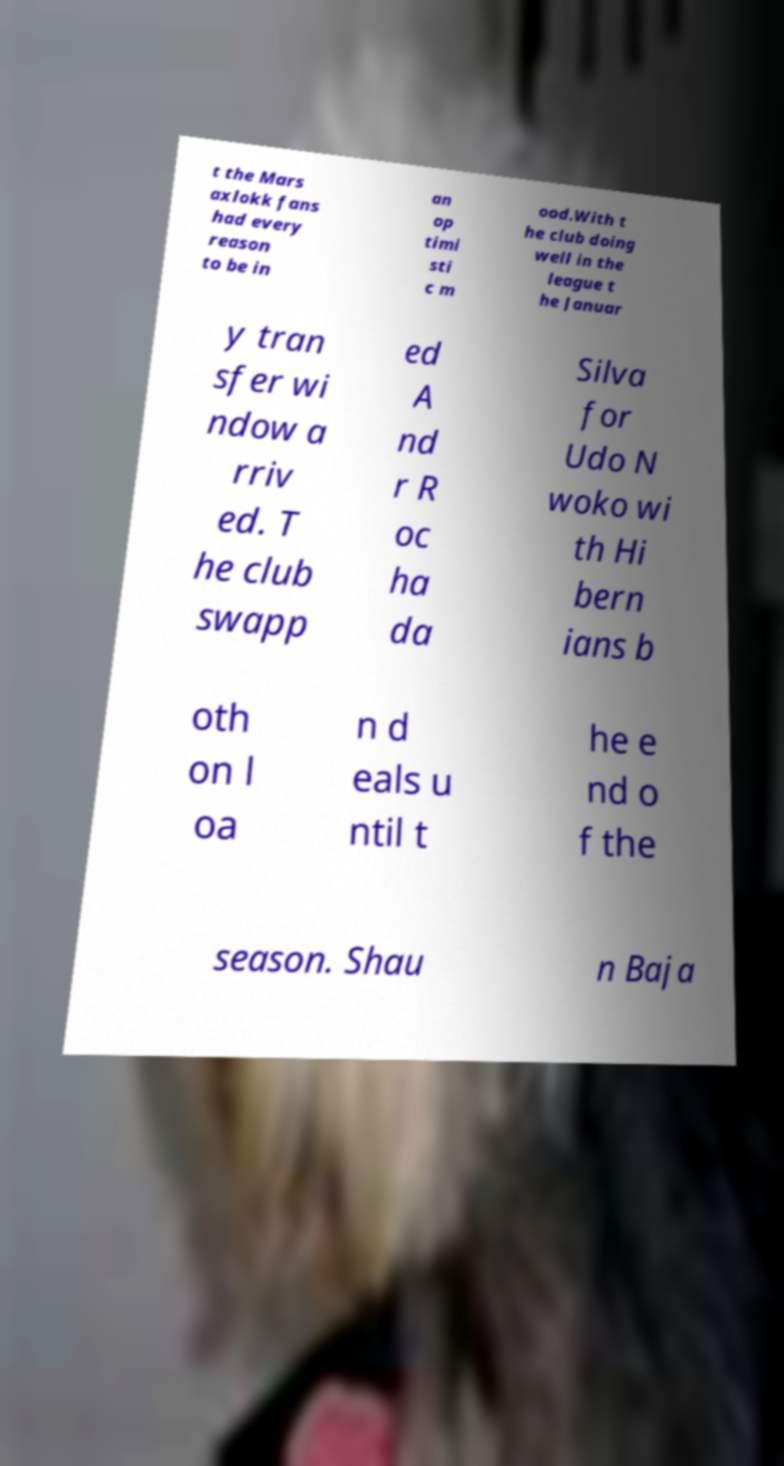Please identify and transcribe the text found in this image. t the Mars axlokk fans had every reason to be in an op timi sti c m ood.With t he club doing well in the league t he Januar y tran sfer wi ndow a rriv ed. T he club swapp ed A nd r R oc ha da Silva for Udo N woko wi th Hi bern ians b oth on l oa n d eals u ntil t he e nd o f the season. Shau n Baja 